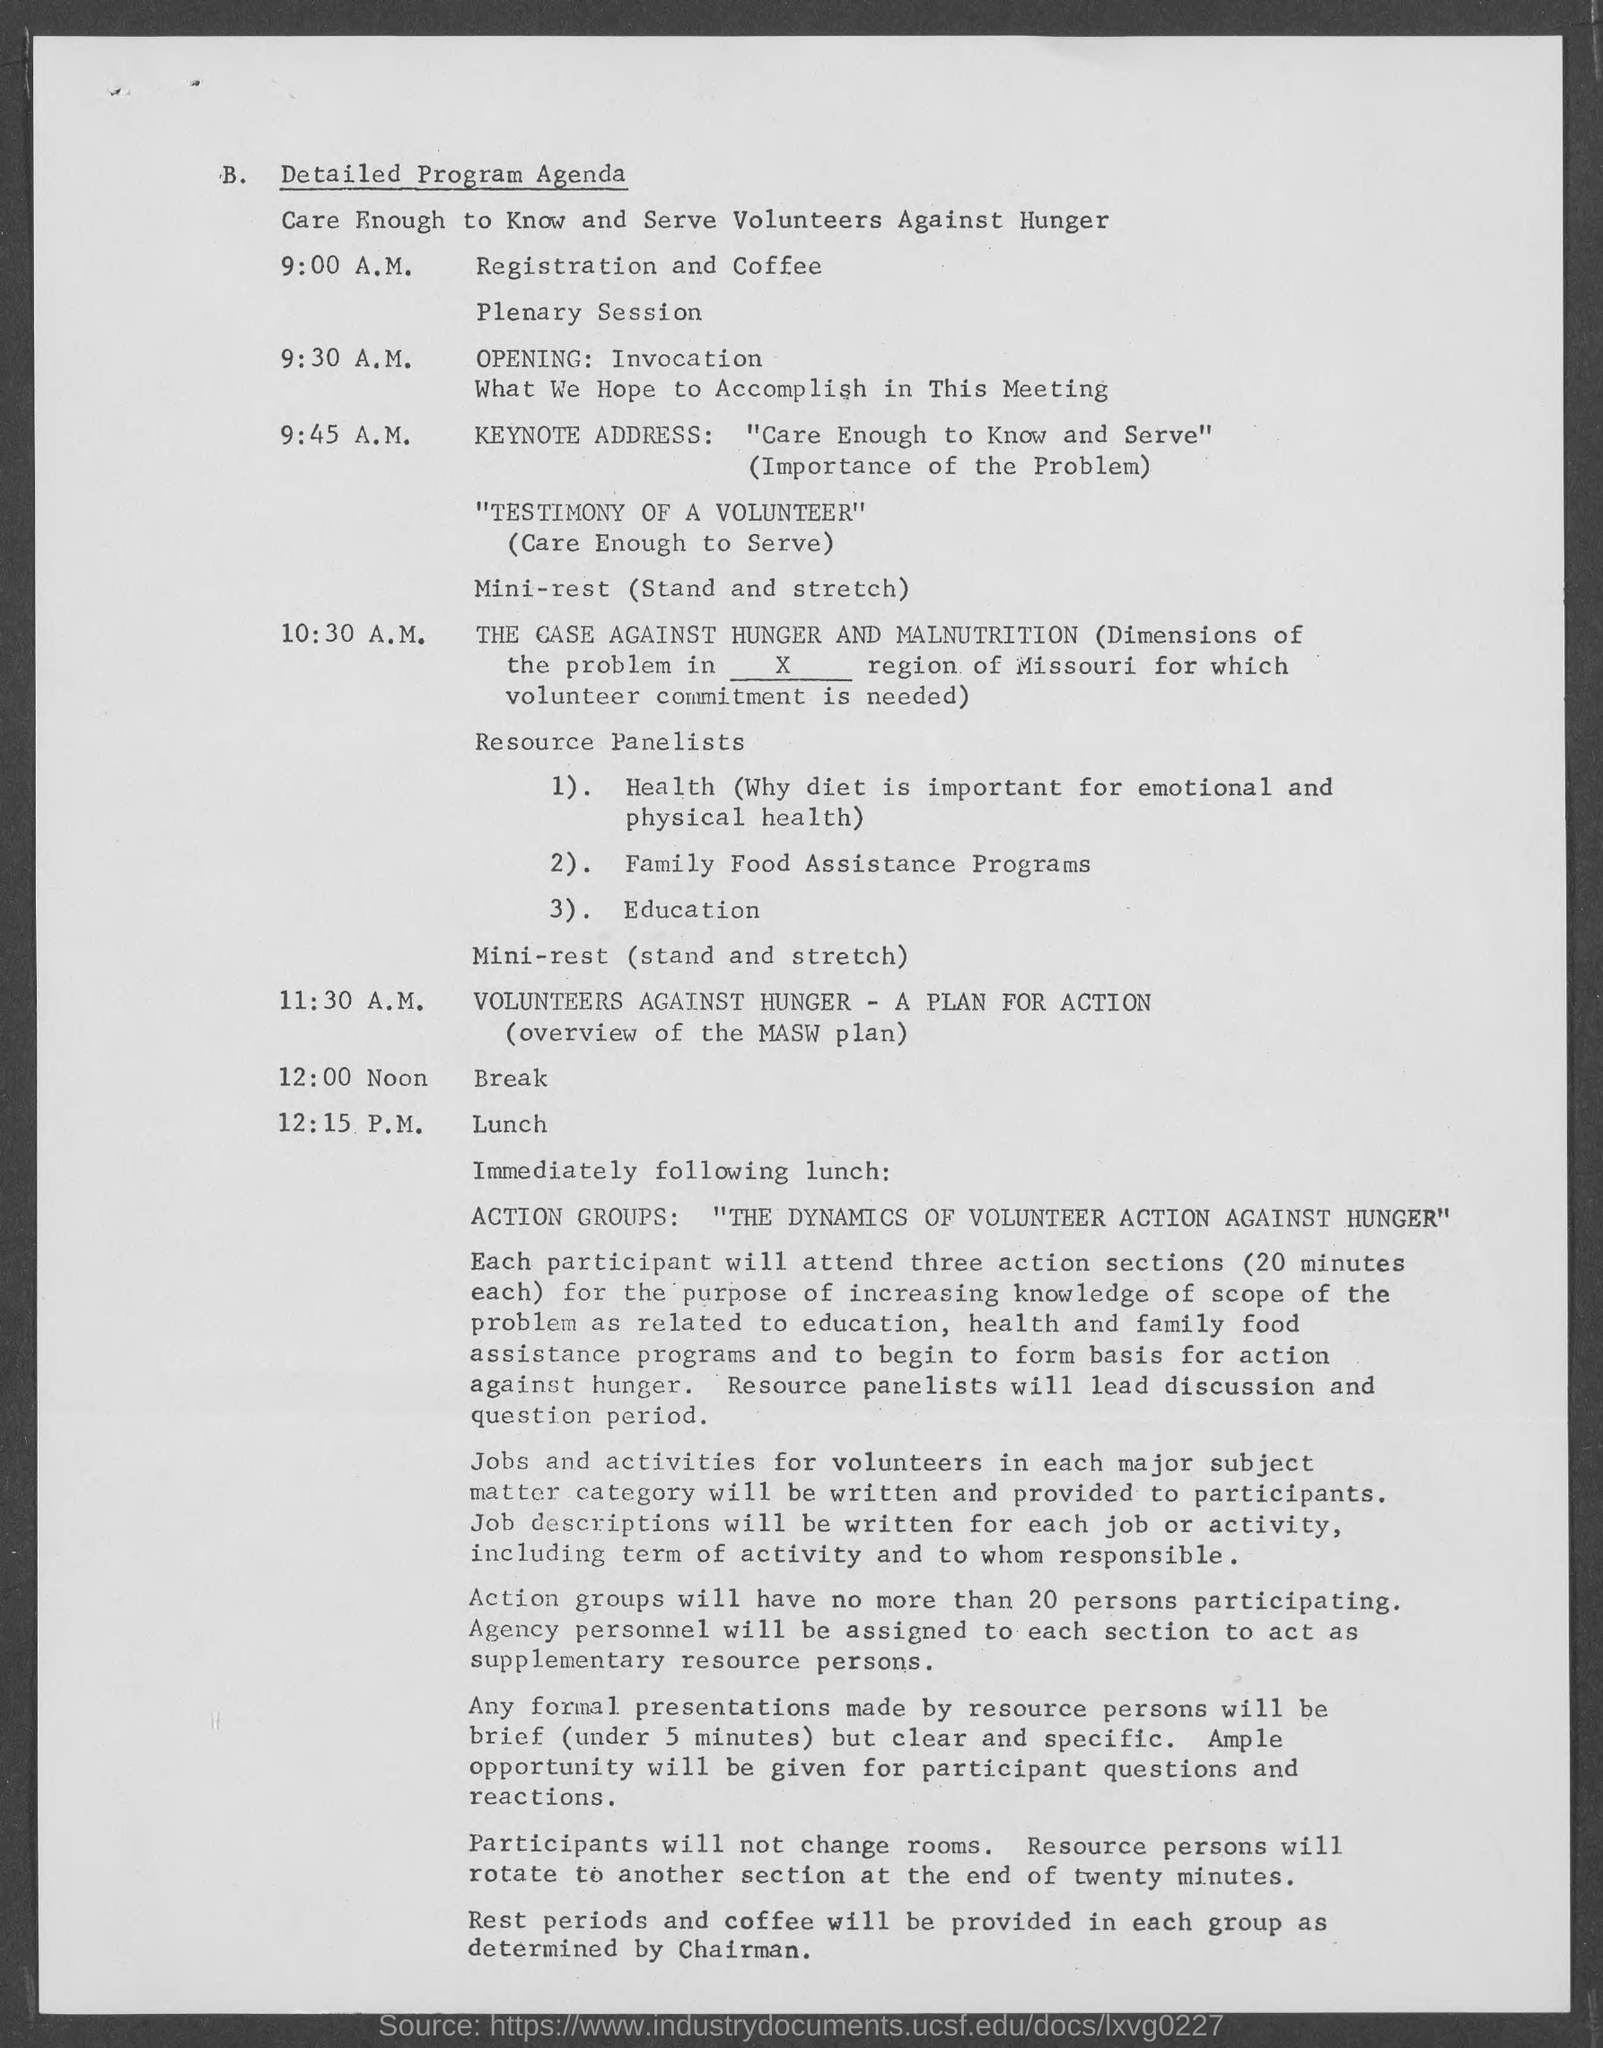Give some essential details in this illustration. Registration and coffee will begin at 9:00 A.M. At 10:30 A.M., the program for the day is "The Case Against Hunger and Malnutrition. 